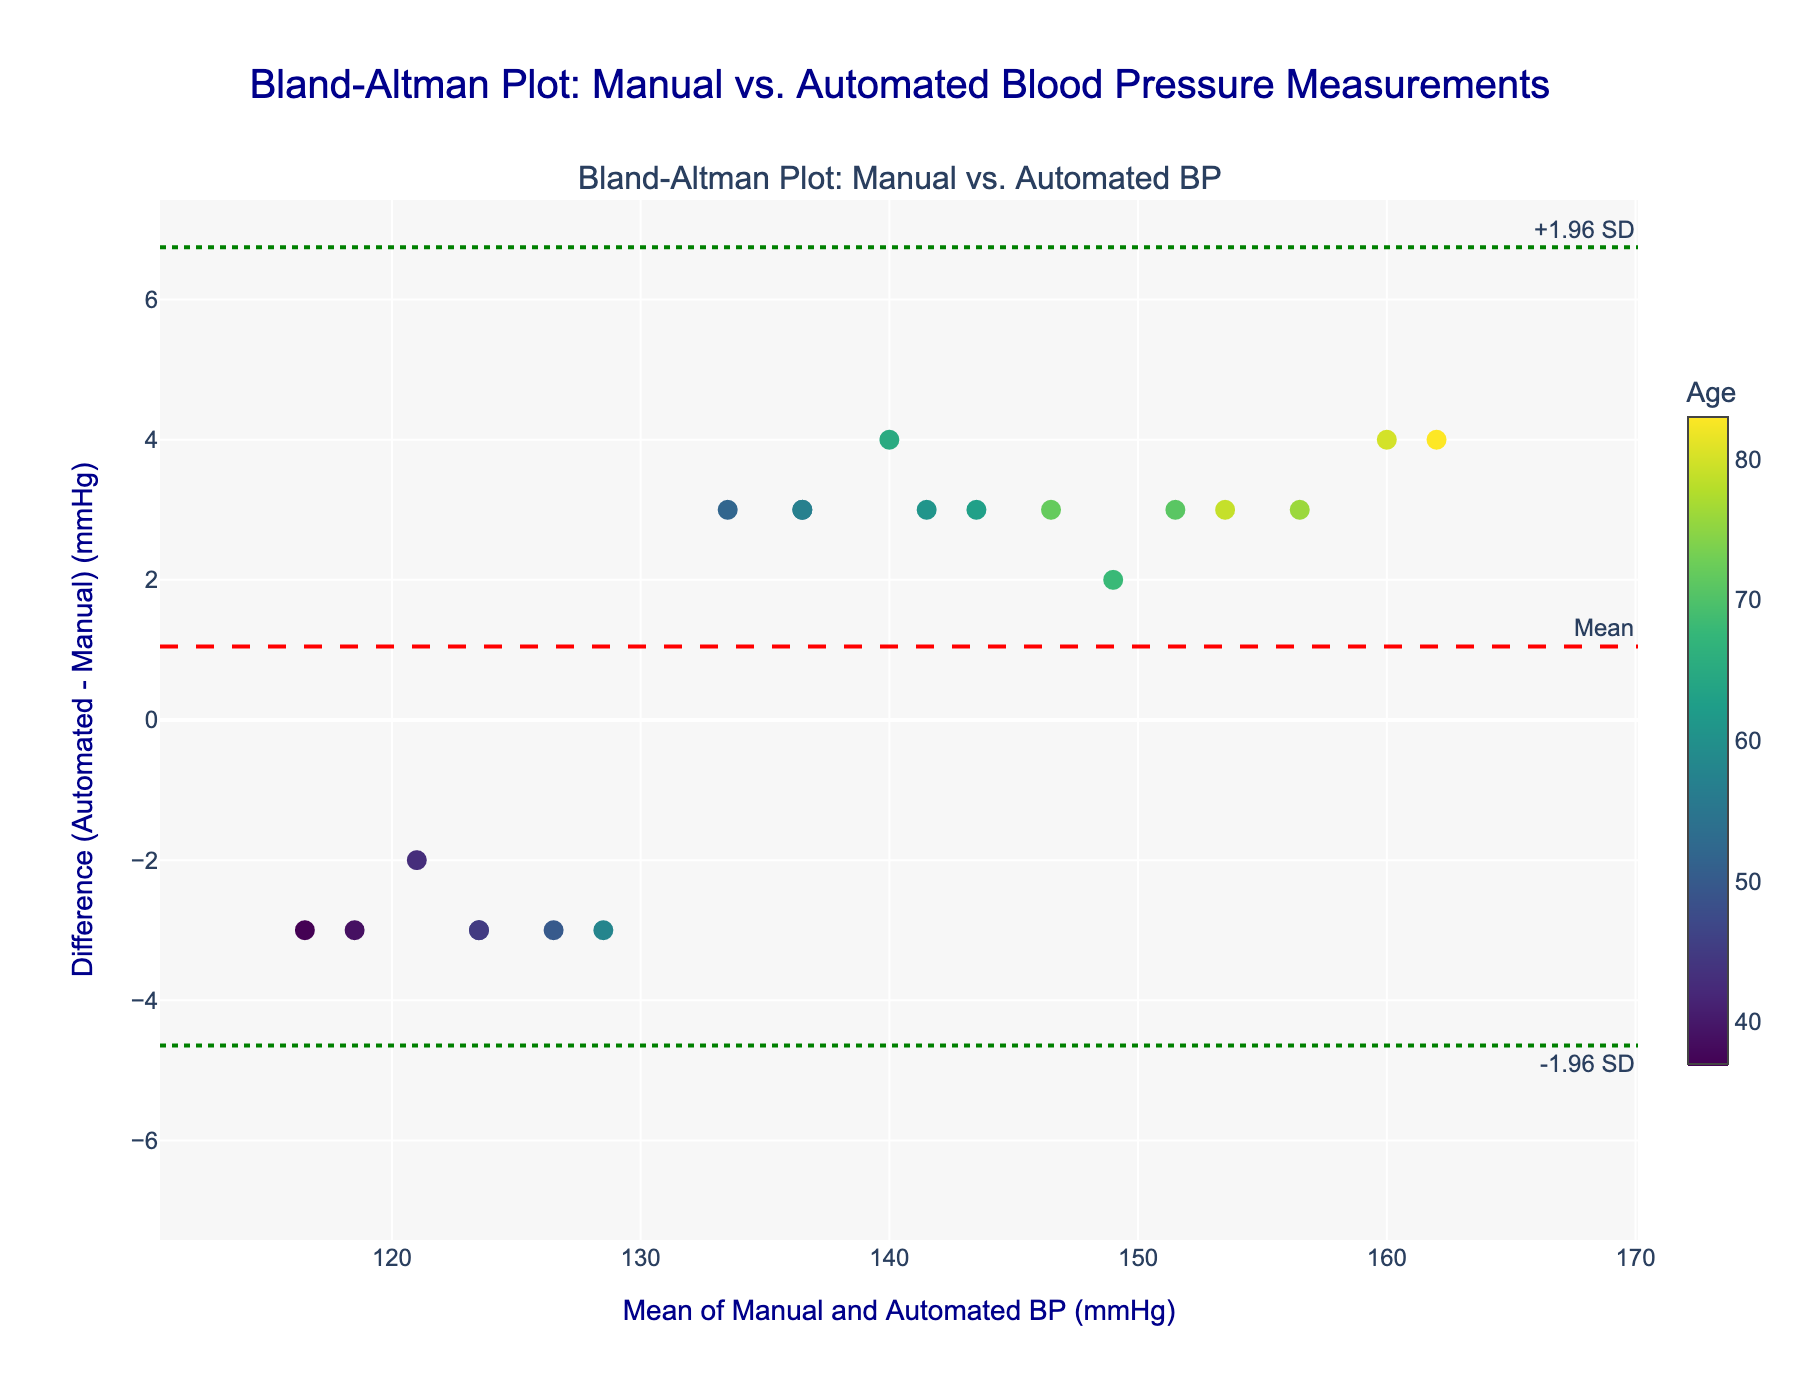What is the title of the plot? The title can be found at the top of the plot. It reads 'Bland-Altman Plot: Manual vs. Automated Blood Pressure Measurements'.
Answer: Bland-Altman Plot: Manual vs. Automated Blood Pressure Measurements What are the units used on the x-axis? The x-axis title states 'Mean of Manual and Automated BP (mmHg)', indicating that the units are in millimeters of mercury (mmHg).
Answer: mmHg What does a positive difference indicate in this plot? A positive difference means that the automated blood pressure measurement was higher than the manual blood pressure measurement. This can be seen on the y-axis, where it indicates 'Difference (Automated - Manual) (mmHg)'.
Answer: Automated BP is higher than Manual BP What is the range of ages represented in the color scale? By observing the color scale legend on the right side of the plot, the age range of the patients represented in the color scale is from 37 to 83.
Answer: 37 to 83 What do the dashed and dotted lines represent? The dashed line in red represents the mean difference, while the dotted lines in green represent the limits of agreement, which are ±1.96 standard deviations from the mean difference.
Answer: Mean difference and ±1.96 SD How many data points have a difference greater than 2 mmHg? By visually inspecting the plot, count the data points that lie above the 2 mmHg mark on the y-axis.
Answer: 11 What is the mean difference between manual and automated BP measurements? The mean difference is represented by the red dashed line and is annotated directly on the plot.
Answer: Red dashed line value Which age group tends to have larger differences in BP measurements? By examining the color intensities of the data points on the plot, it can be observed that older age groups (those closer to a yellow-green hue) have larger positive differences.
Answer: Older age groups Determine the range for the limits of agreement in BP measurements. The limits of agreement are given by the dotted green lines. These are approximately around ±3.92 (calculation might be necessary based on mean +/− 1.96*SD).
Answer: ±3.92 Is there any visible trend between age and the difference in BP measurements? The colors of the data points, which represent different ages, show that older patients often have positive differences, while younger patients tend to cluster around zero or negative differences.
Answer: Older patients have positive differences, younger patients cluster around zero or negative 